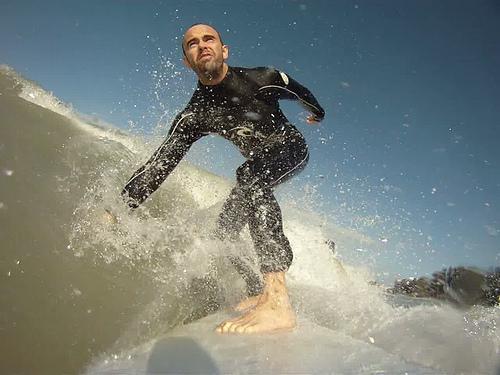Where does he have his right hand?
Concise answer only. In water. What object is the camera resting on?
Write a very short answer. Surfboard. What is the color of the water?
Quick response, please. Green. Is the man wearing shoes?
Write a very short answer. No. 